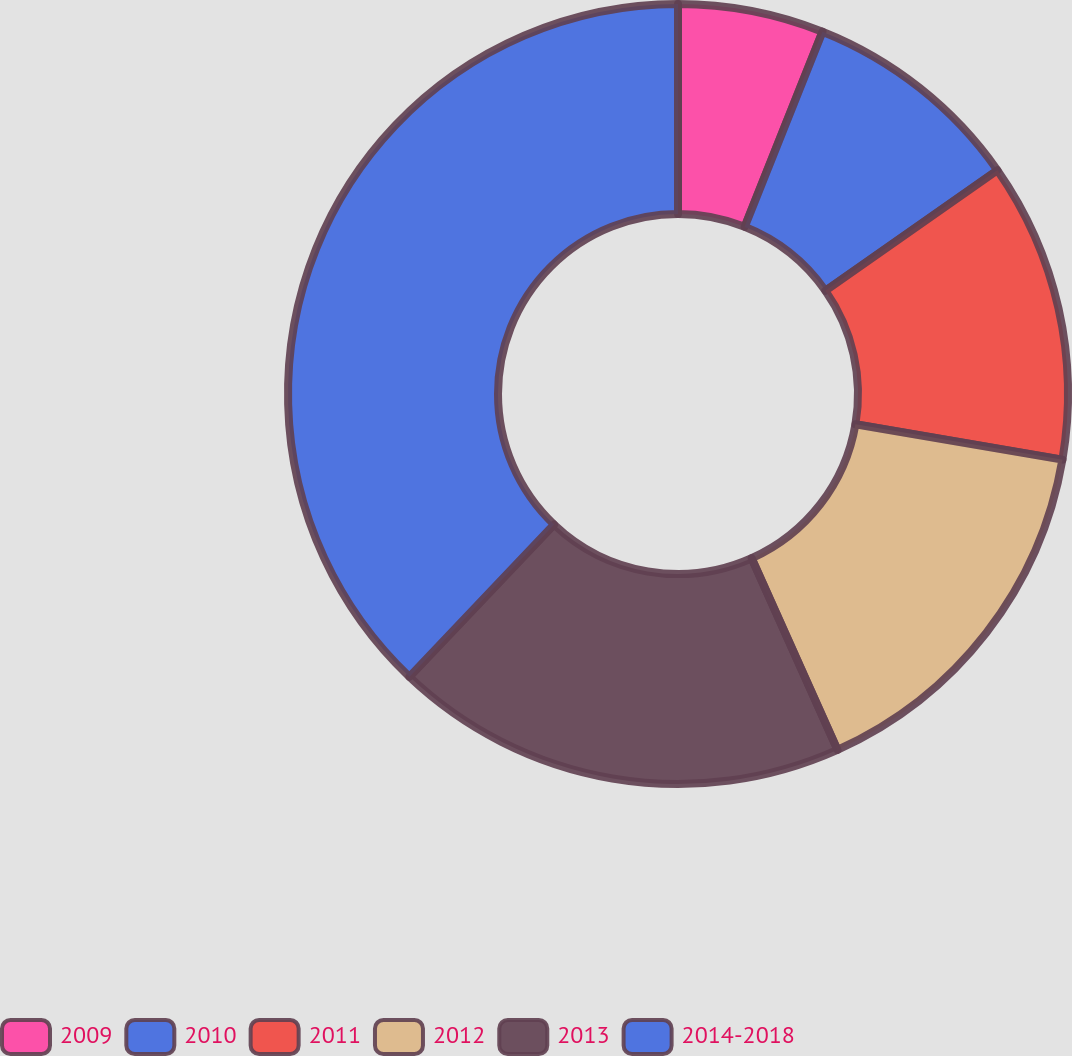Convert chart to OTSL. <chart><loc_0><loc_0><loc_500><loc_500><pie_chart><fcel>2009<fcel>2010<fcel>2011<fcel>2012<fcel>2013<fcel>2014-2018<nl><fcel>6.04%<fcel>9.23%<fcel>12.42%<fcel>15.6%<fcel>18.79%<fcel>37.91%<nl></chart> 